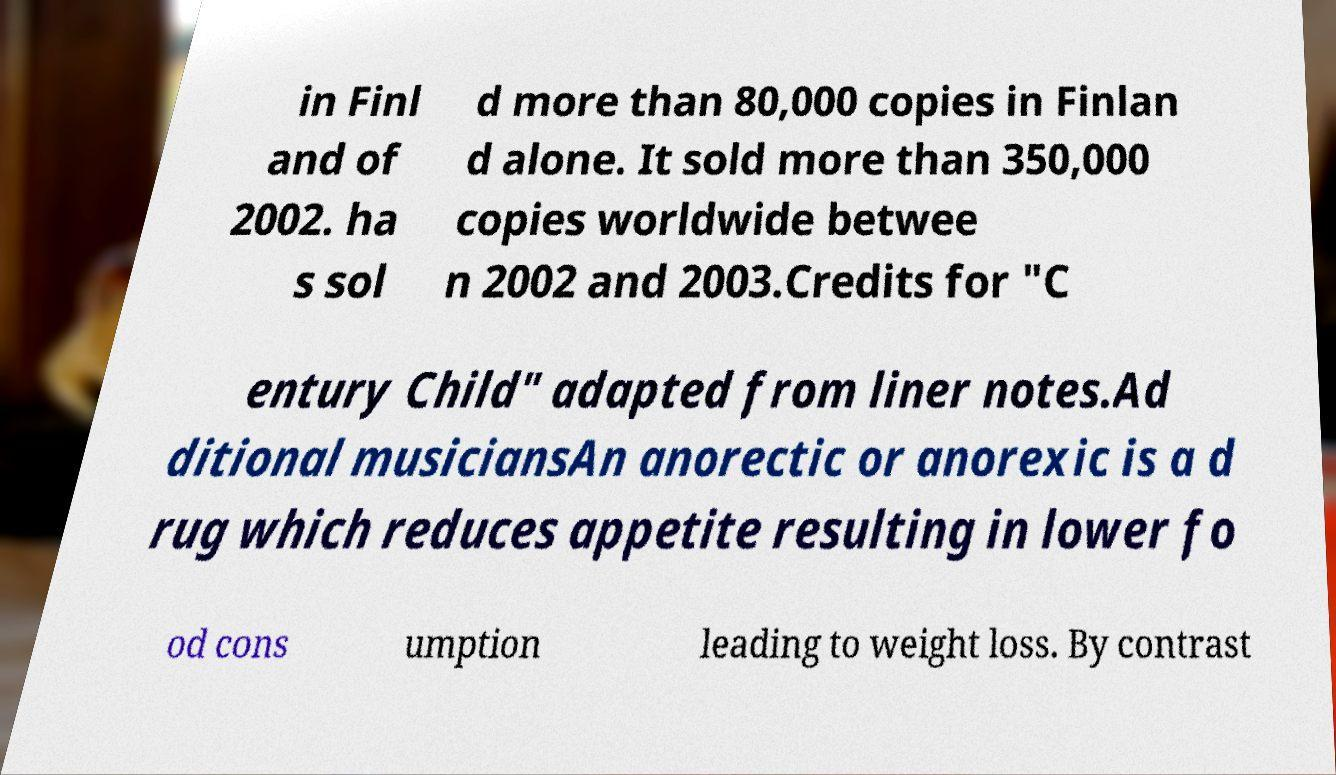Could you assist in decoding the text presented in this image and type it out clearly? in Finl and of 2002. ha s sol d more than 80,000 copies in Finlan d alone. It sold more than 350,000 copies worldwide betwee n 2002 and 2003.Credits for "C entury Child" adapted from liner notes.Ad ditional musiciansAn anorectic or anorexic is a d rug which reduces appetite resulting in lower fo od cons umption leading to weight loss. By contrast 